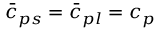Convert formula to latex. <formula><loc_0><loc_0><loc_500><loc_500>\bar { c } _ { p s } = \bar { c } _ { p l } = c _ { p }</formula> 